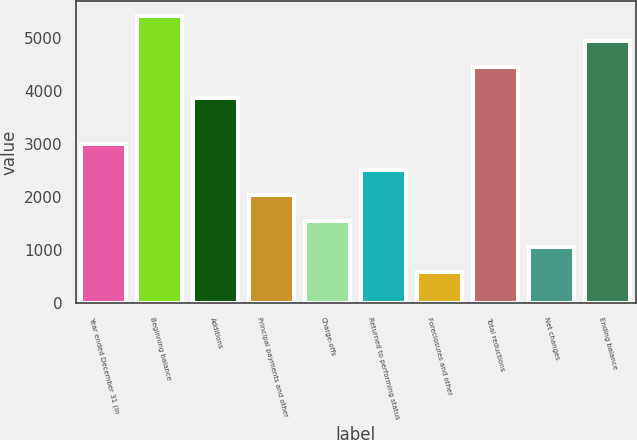<chart> <loc_0><loc_0><loc_500><loc_500><bar_chart><fcel>Year ended December 31 (in<fcel>Beginning balance<fcel>Additions<fcel>Principal payments and other<fcel>Charge-offs<fcel>Returned to performing status<fcel>Foreclosures and other<fcel>Total reductions<fcel>Net changes<fcel>Ending balance<nl><fcel>2997.5<fcel>5417.2<fcel>3858<fcel>2031.3<fcel>1548.2<fcel>2514.4<fcel>582<fcel>4451<fcel>1065.1<fcel>4934.1<nl></chart> 